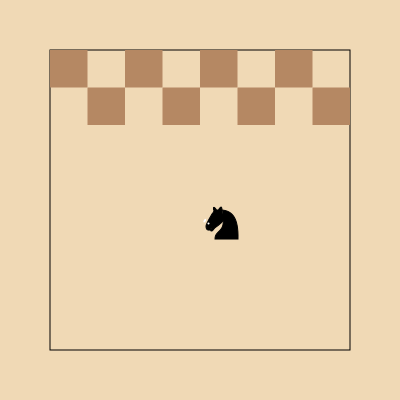Given the knight's position on the chessboard, how many legal moves can it make? To solve this problem, we need to follow these steps:

1. Identify the knight's current position:
   The knight is located at the center of the board, which corresponds to square e4 in chess notation.

2. Recall the knight's movement pattern:
   A knight moves in an "L" shape: 2 squares in one direction and then 1 square perpendicular to that direction.

3. Enumerate all possible moves from e4:
   a) 2 up, 1 right: g5
   b) 2 up, 1 left: c5
   c) 2 right, 1 up: f6
   d) 2 right, 1 down: f2
   e) 2 down, 1 right: g3
   f) 2 down, 1 left: c3
   g) 2 left, 1 up: d6
   h) 2 left, 1 down: d2

4. Check if all moves are within the board boundaries:
   All 8 potential moves listed above remain on the 8x8 chessboard.

5. Count the number of legal moves:
   Since all 8 potential moves are within the board boundaries, the knight can make 8 legal moves from its current position.
Answer: 8 